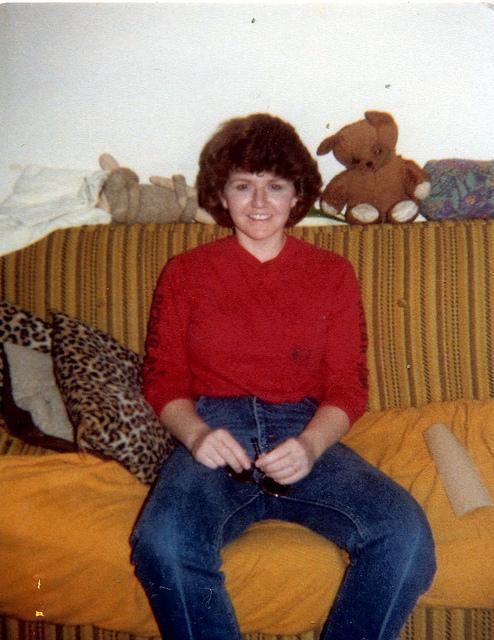How many people are there?
Give a very brief answer. 1. How many teddy bears can be seen?
Give a very brief answer. 2. 